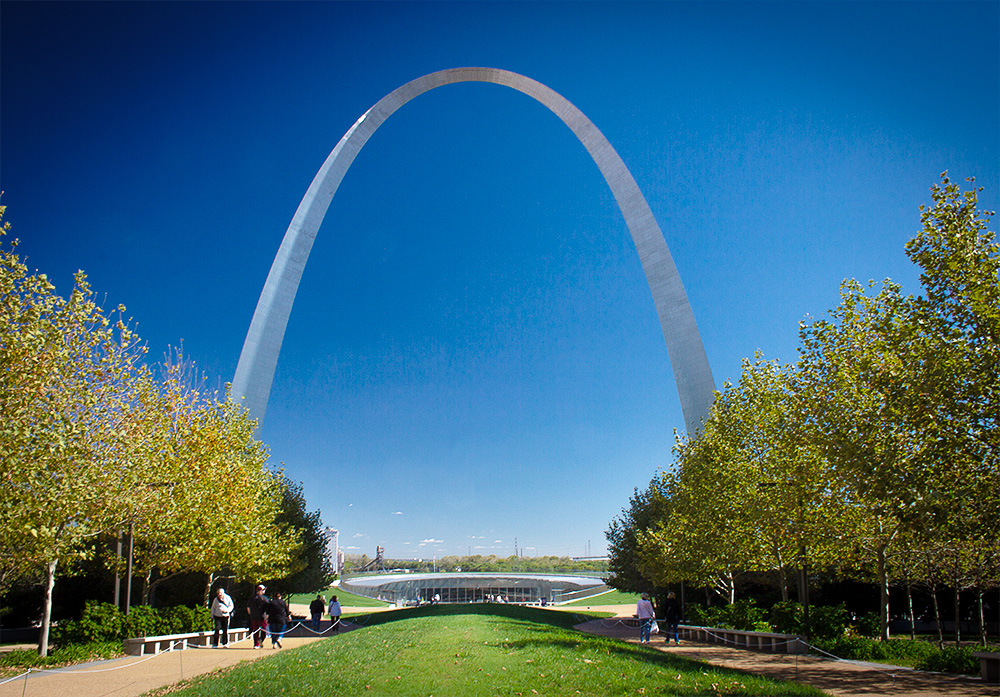What emotions does this image evoke? The image evokes a sense of awe and wonder, emphasizing the blend of human ingenuity and natural beauty. The grandeur of the Gateway Arch against the expansive sky creates an inspiring scene, while the peaceful park setting with people strolling fosters feelings of peace and happiness. Can you give me a creative short story that this image might inspire? In a land where dreams reach the sky, the Gateway Arch was a portal to a realm of endless possibilities. Each person passing beneath its gleaming archway found their inner potential unlocked, embarking on a journey to discover and achieve their wildest dreams. Imagine what it would be like to see this arch from a bird's-eye view. From a bird's-eye view, the Gateway Arch looks like a stunning silver crescent glistening in the sunlight against a backdrop of the sprawling cityscape of St. Louis. The sprawling park beneath it, with its meticulously landscaped trees and pathways, forms a perfect, green frame for the arch. The Mississippi River winding its way through the city adds a touch of natural elegance to the panoramic view. The entire scene embodies a harmonic blend of urban achievement and natural beauty, a breathtaking sight that highlights the arch's iconic status. 